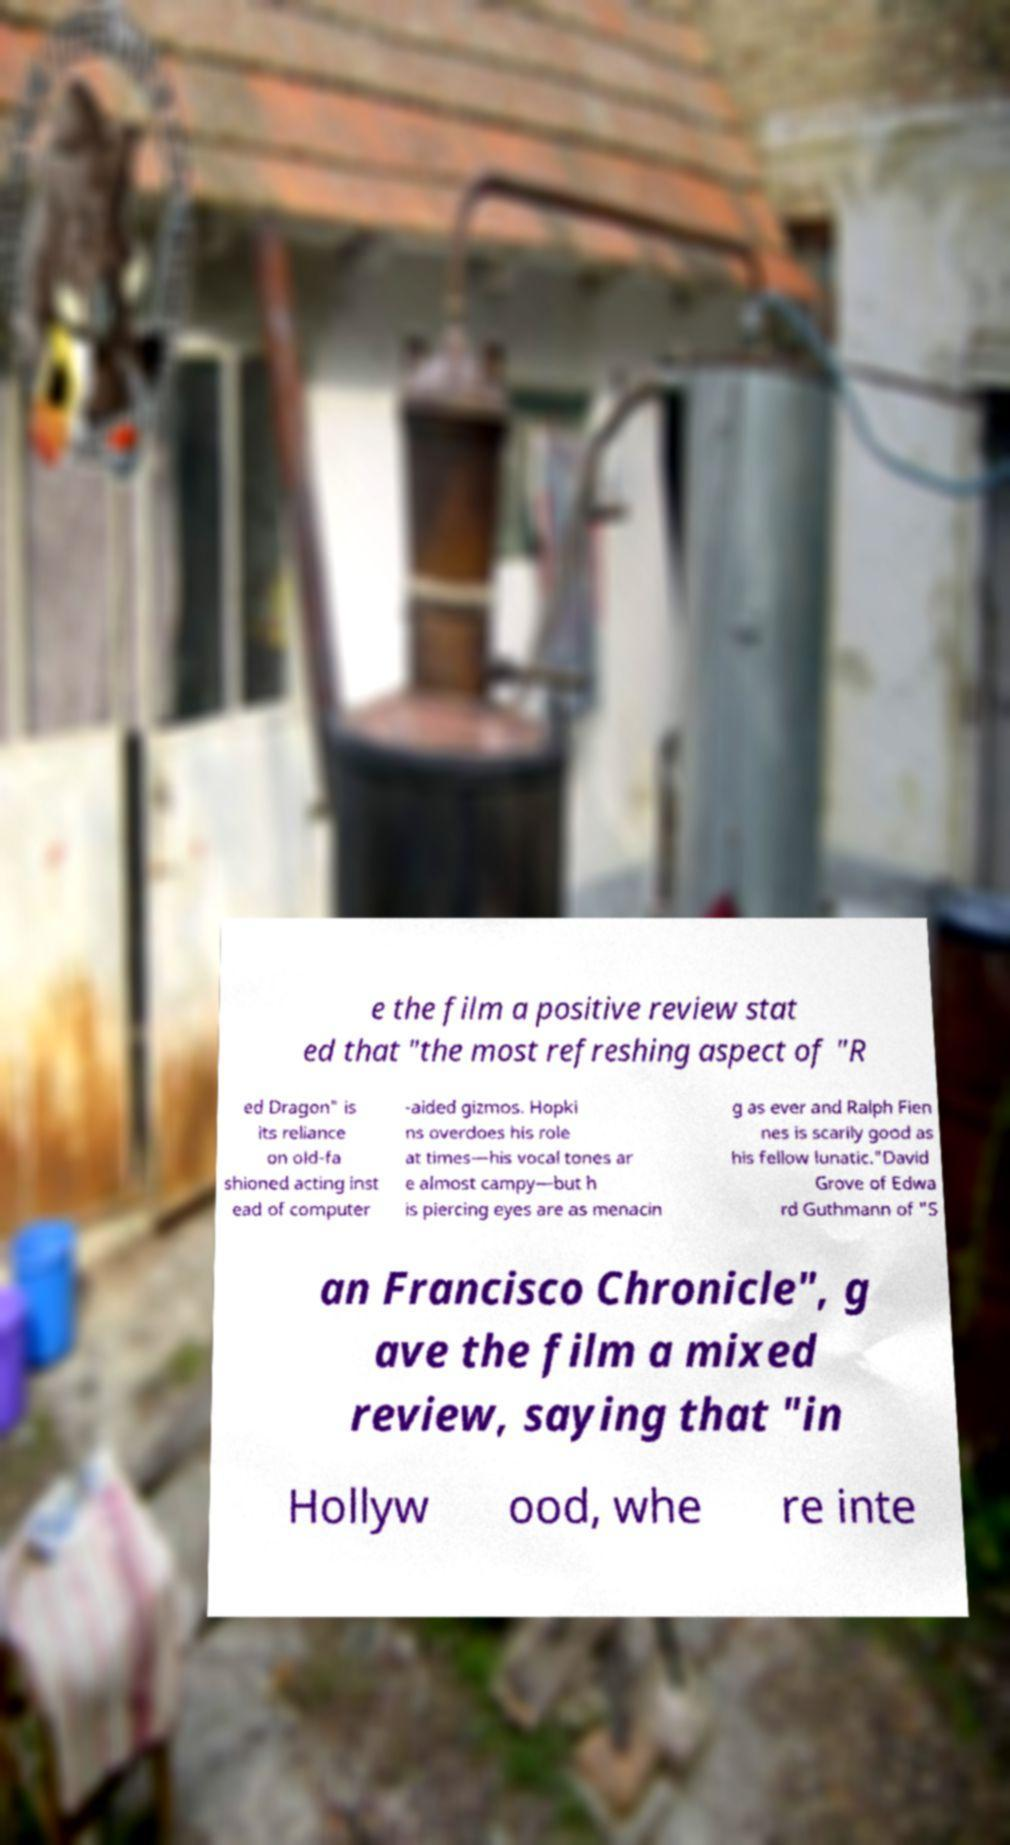Can you accurately transcribe the text from the provided image for me? e the film a positive review stat ed that "the most refreshing aspect of "R ed Dragon" is its reliance on old-fa shioned acting inst ead of computer -aided gizmos. Hopki ns overdoes his role at times—his vocal tones ar e almost campy—but h is piercing eyes are as menacin g as ever and Ralph Fien nes is scarily good as his fellow lunatic."David Grove of Edwa rd Guthmann of "S an Francisco Chronicle", g ave the film a mixed review, saying that "in Hollyw ood, whe re inte 